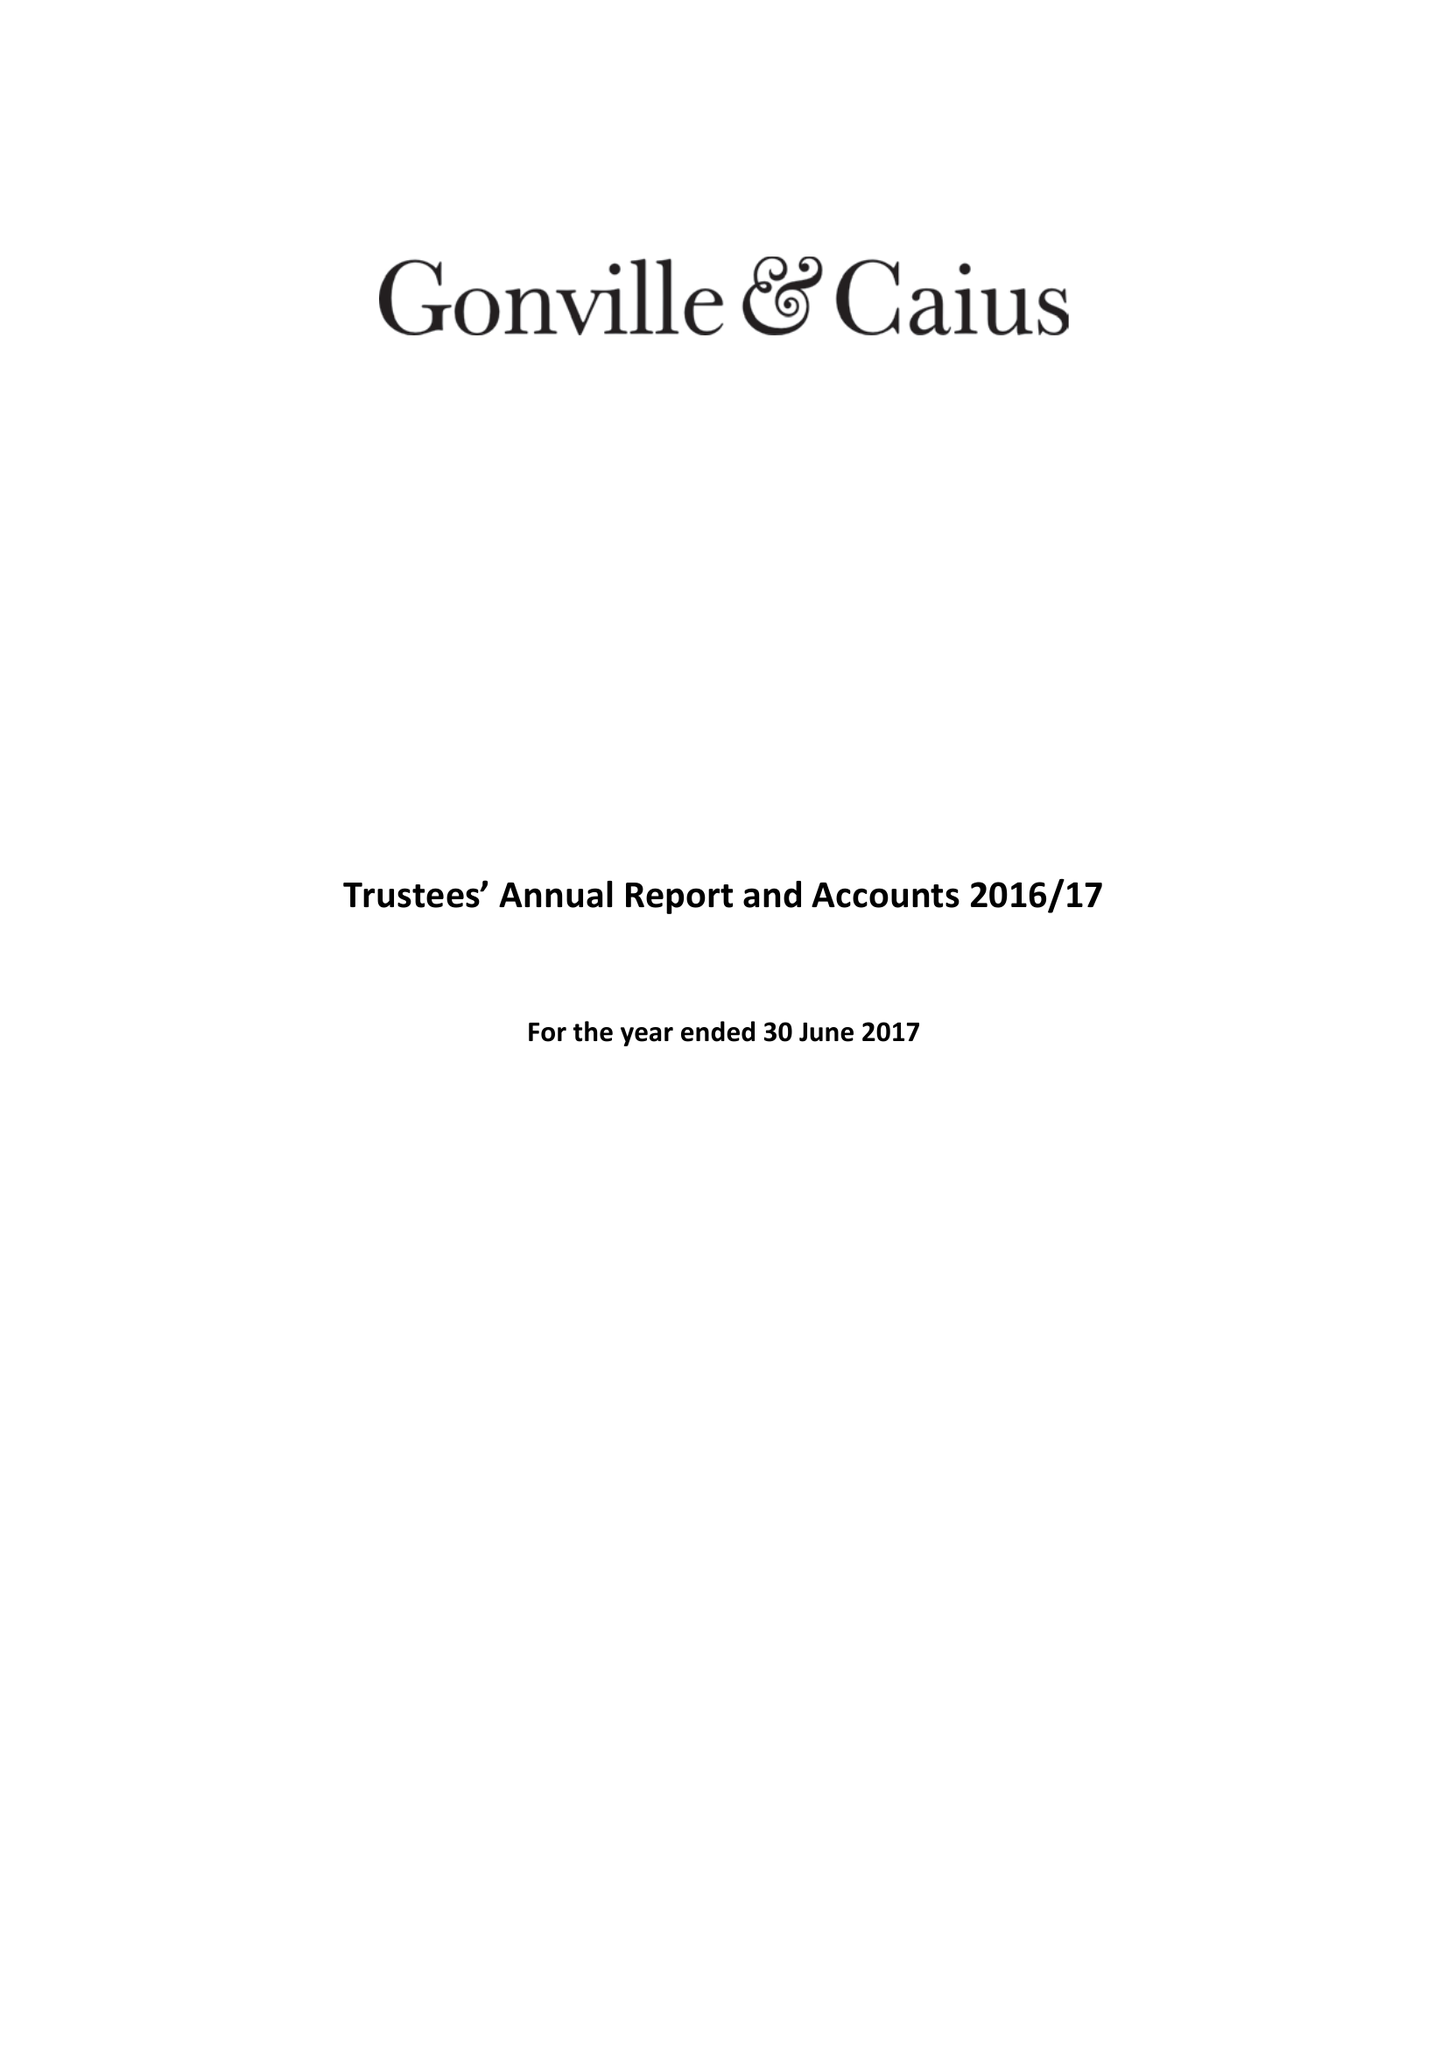What is the value for the address__post_town?
Answer the question using a single word or phrase. CAMBRIDGE 